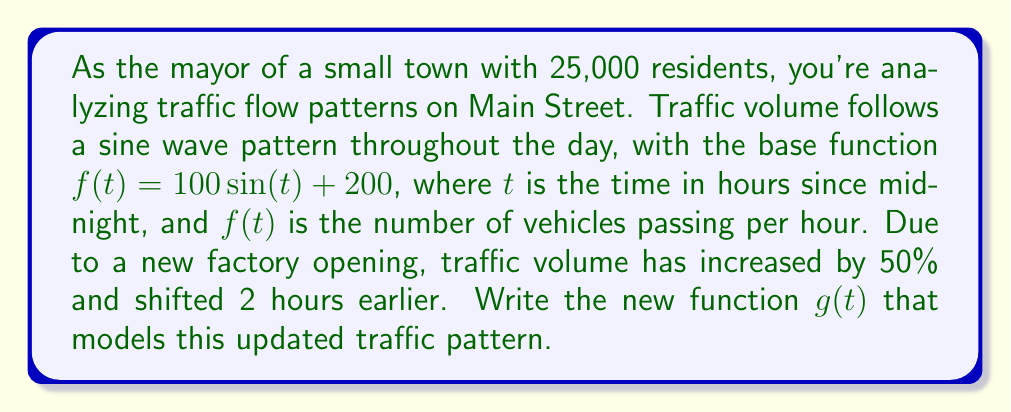Can you answer this question? To solve this problem, we need to apply multiple transformations to the original function $f(t) = 100\sin(t) + 200$. Let's break it down step-by-step:

1. Increase in traffic volume by 50%:
   This is a vertical stretch by a factor of 1.5. We multiply the amplitude and vertical shift by 1.5:
   $f_1(t) = 150\sin(t) + 300$

2. Shift 2 hours earlier:
   This is a horizontal shift to the right by 2 units. We replace $t$ with $(t+2)$:
   $g(t) = 150\sin(t+2) + 300$

The resulting function $g(t)$ combines both transformations:
- The amplitude has increased from 100 to 150
- The vertical shift has increased from 200 to 300
- The phase shift is 2 units to the left (which is equivalent to shifting the traffic pattern 2 hours earlier)

Therefore, the new function $g(t)$ that models the updated traffic pattern is:

$$g(t) = 150\sin(t+2) + 300$$

This function represents the number of vehicles passing per hour at time $t$ hours since midnight, with the increased volume and earlier shift due to the new factory.
Answer: $g(t) = 150\sin(t+2) + 300$ 